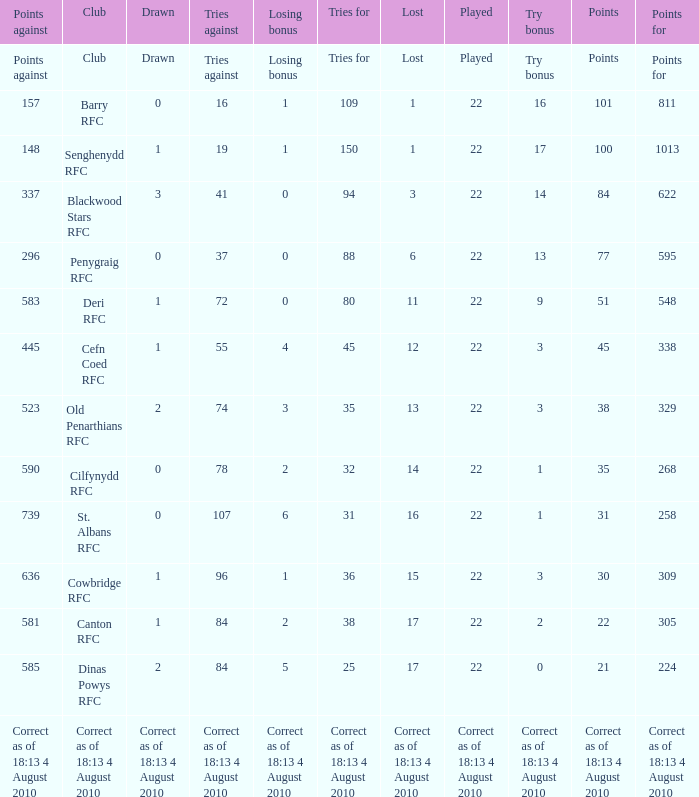What is the lost when the club was Barry RFC? 1.0. 